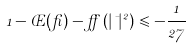Convert formula to latex. <formula><loc_0><loc_0><loc_500><loc_500>1 - \phi ( \beta ) - \alpha \left ( | \mu | ^ { 2 } \right ) \leqslant - \frac { 1 } { 2 7 }</formula> 